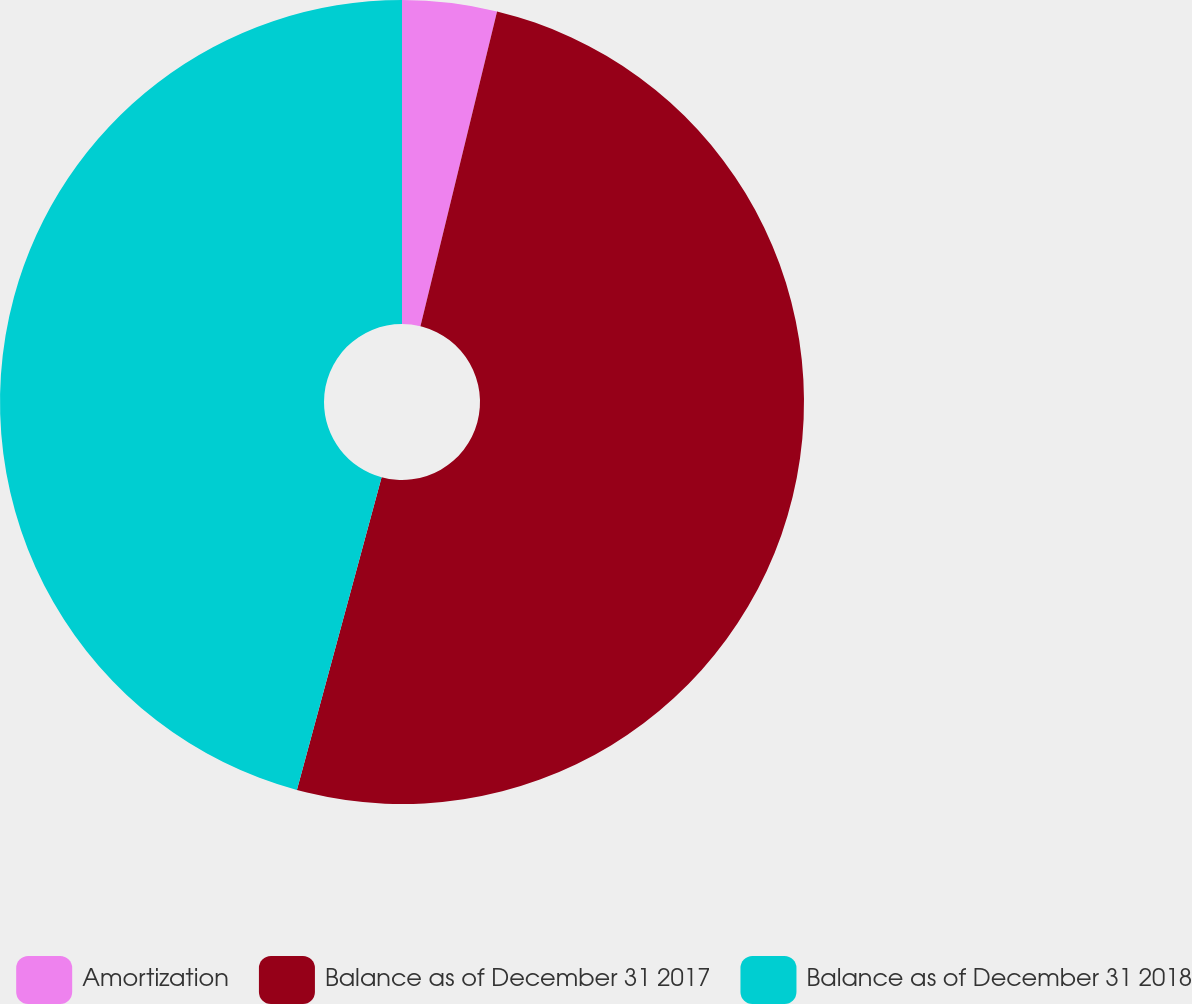<chart> <loc_0><loc_0><loc_500><loc_500><pie_chart><fcel>Amortization<fcel>Balance as of December 31 2017<fcel>Balance as of December 31 2018<nl><fcel>3.8%<fcel>50.41%<fcel>45.79%<nl></chart> 